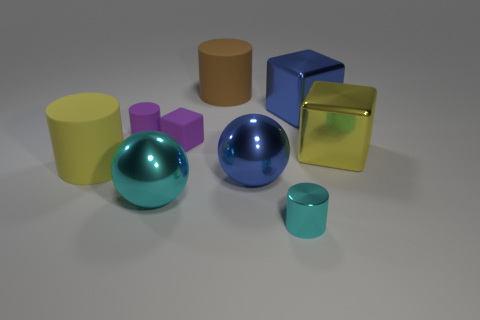Add 1 brown shiny objects. How many objects exist? 10 Subtract all metal blocks. How many blocks are left? 1 Subtract all spheres. How many objects are left? 7 Subtract 2 cylinders. How many cylinders are left? 2 Subtract 0 brown cubes. How many objects are left? 9 Subtract all gray blocks. Subtract all green balls. How many blocks are left? 3 Subtract all blue spheres. Subtract all large cyan things. How many objects are left? 7 Add 2 large shiny cubes. How many large shiny cubes are left? 4 Add 6 blue metal cubes. How many blue metal cubes exist? 7 Subtract all purple cylinders. How many cylinders are left? 3 